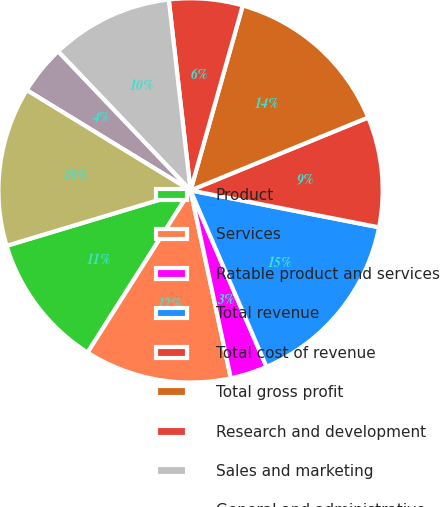Convert chart to OTSL. <chart><loc_0><loc_0><loc_500><loc_500><pie_chart><fcel>Product<fcel>Services<fcel>Ratable product and services<fcel>Total revenue<fcel>Total cost of revenue<fcel>Total gross profit<fcel>Research and development<fcel>Sales and marketing<fcel>General and administrative<fcel>Total operating expenses<nl><fcel>11.34%<fcel>12.37%<fcel>3.11%<fcel>15.45%<fcel>9.28%<fcel>14.42%<fcel>6.19%<fcel>10.31%<fcel>4.14%<fcel>13.4%<nl></chart> 